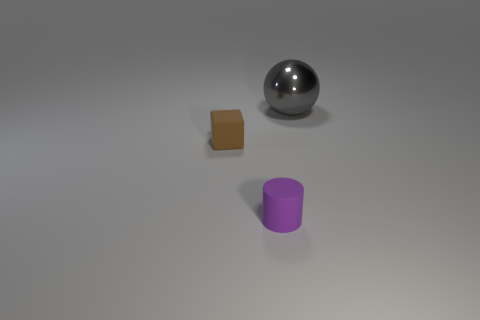Add 3 large shiny balls. How many objects exist? 6 Subtract all cubes. How many objects are left? 2 Subtract all small blue rubber blocks. Subtract all purple objects. How many objects are left? 2 Add 3 big gray balls. How many big gray balls are left? 4 Add 2 small blue metallic objects. How many small blue metallic objects exist? 2 Subtract 0 green blocks. How many objects are left? 3 